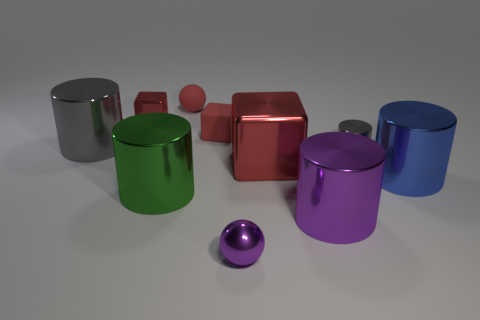There is a purple shiny cylinder; is it the same size as the gray metal cylinder that is on the left side of the green thing?
Offer a terse response. Yes. The thing that is both behind the big gray shiny object and on the left side of the big green metal cylinder is what color?
Your answer should be very brief. Red. What number of things are either tiny balls that are in front of the big purple cylinder or big metallic objects that are behind the large blue cylinder?
Ensure brevity in your answer.  3. The shiny cube in front of the gray cylinder in front of the gray metal object left of the tiny gray cylinder is what color?
Your response must be concise. Red. Are there any other metallic objects that have the same shape as the large gray shiny object?
Give a very brief answer. Yes. What number of green objects are there?
Offer a terse response. 1. What is the shape of the blue object?
Offer a terse response. Cylinder. What number of brown matte balls are the same size as the matte block?
Your answer should be very brief. 0. Does the large green thing have the same shape as the big purple metal thing?
Keep it short and to the point. Yes. What is the color of the large cylinder that is right of the large metal cylinder that is in front of the large green shiny cylinder?
Offer a very short reply. Blue. 